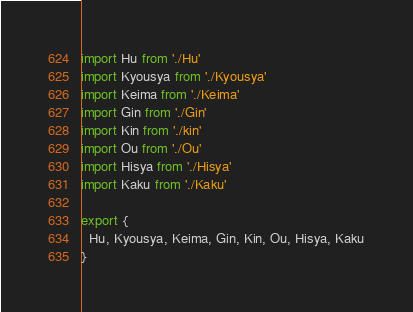<code> <loc_0><loc_0><loc_500><loc_500><_JavaScript_>import Hu from './Hu'
import Kyousya from './Kyousya'
import Keima from './Keima'
import Gin from './Gin'
import Kin from './kin'
import Ou from './Ou'
import Hisya from './Hisya'
import Kaku from './Kaku'

export {
  Hu, Kyousya, Keima, Gin, Kin, Ou, Hisya, Kaku
}
</code> 